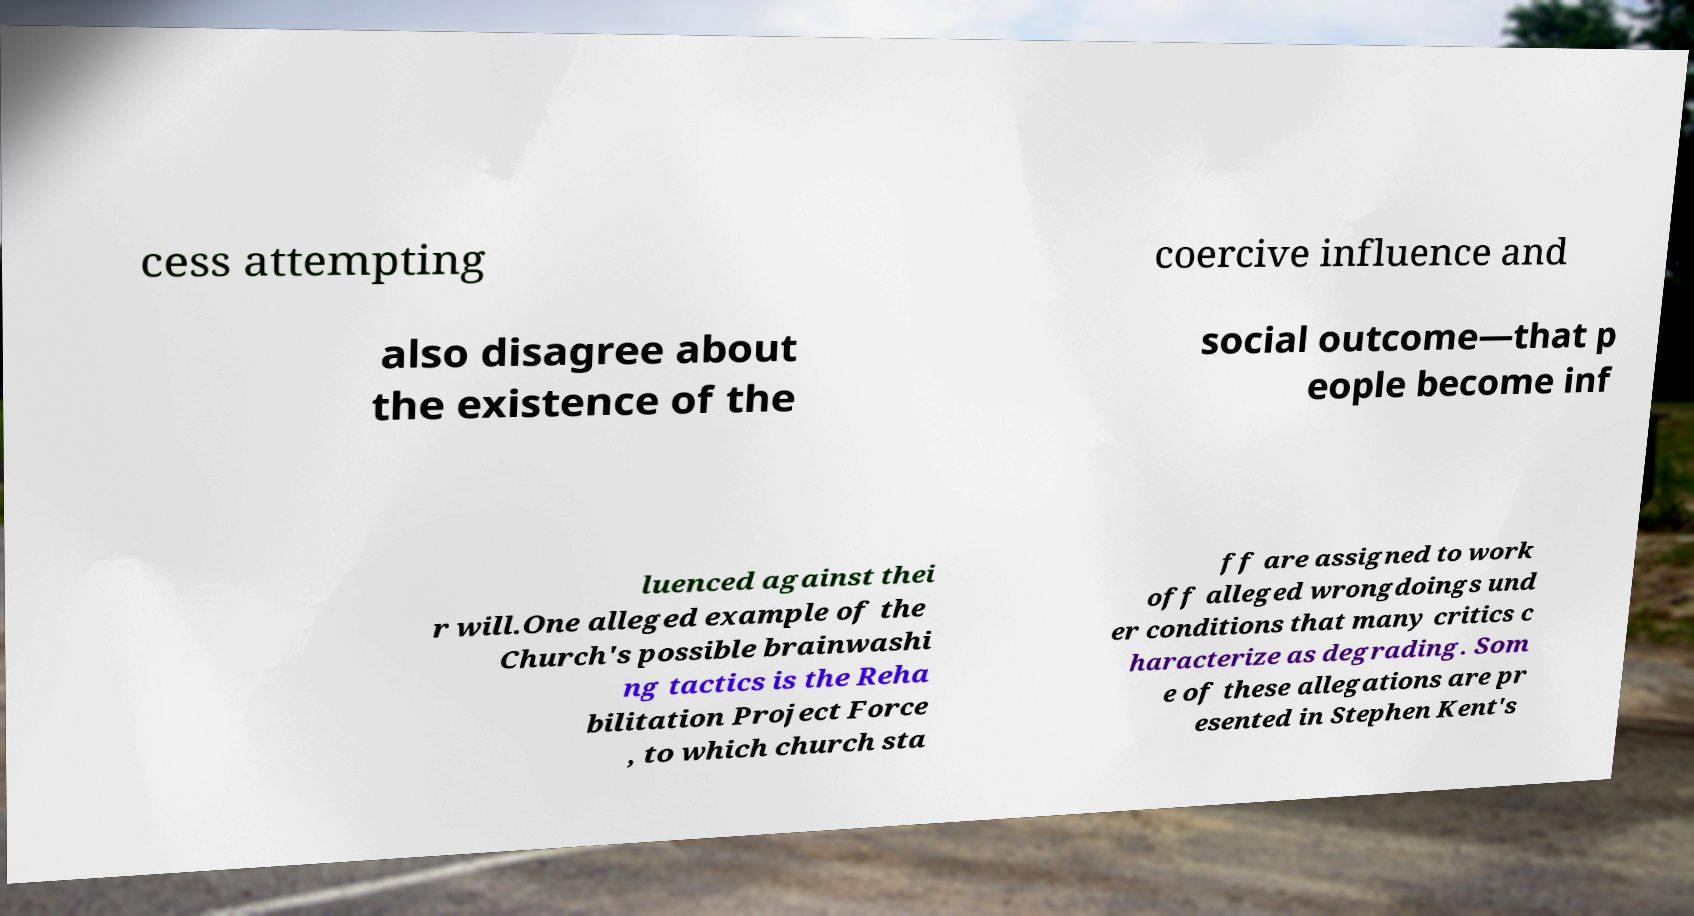Please identify and transcribe the text found in this image. cess attempting coercive influence and also disagree about the existence of the social outcome—that p eople become inf luenced against thei r will.One alleged example of the Church's possible brainwashi ng tactics is the Reha bilitation Project Force , to which church sta ff are assigned to work off alleged wrongdoings und er conditions that many critics c haracterize as degrading. Som e of these allegations are pr esented in Stephen Kent's 